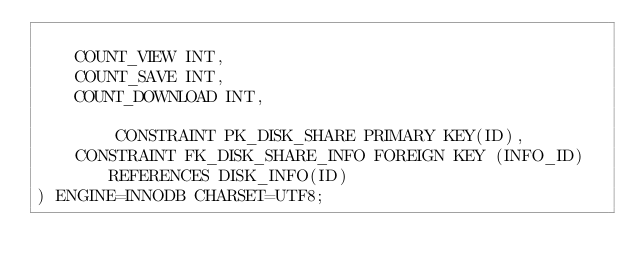<code> <loc_0><loc_0><loc_500><loc_500><_SQL_>
	COUNT_VIEW INT,
	COUNT_SAVE INT,
	COUNT_DOWNLOAD INT,

        CONSTRAINT PK_DISK_SHARE PRIMARY KEY(ID),
	CONSTRAINT FK_DISK_SHARE_INFO FOREIGN KEY (INFO_ID) REFERENCES DISK_INFO(ID)
) ENGINE=INNODB CHARSET=UTF8;



</code> 